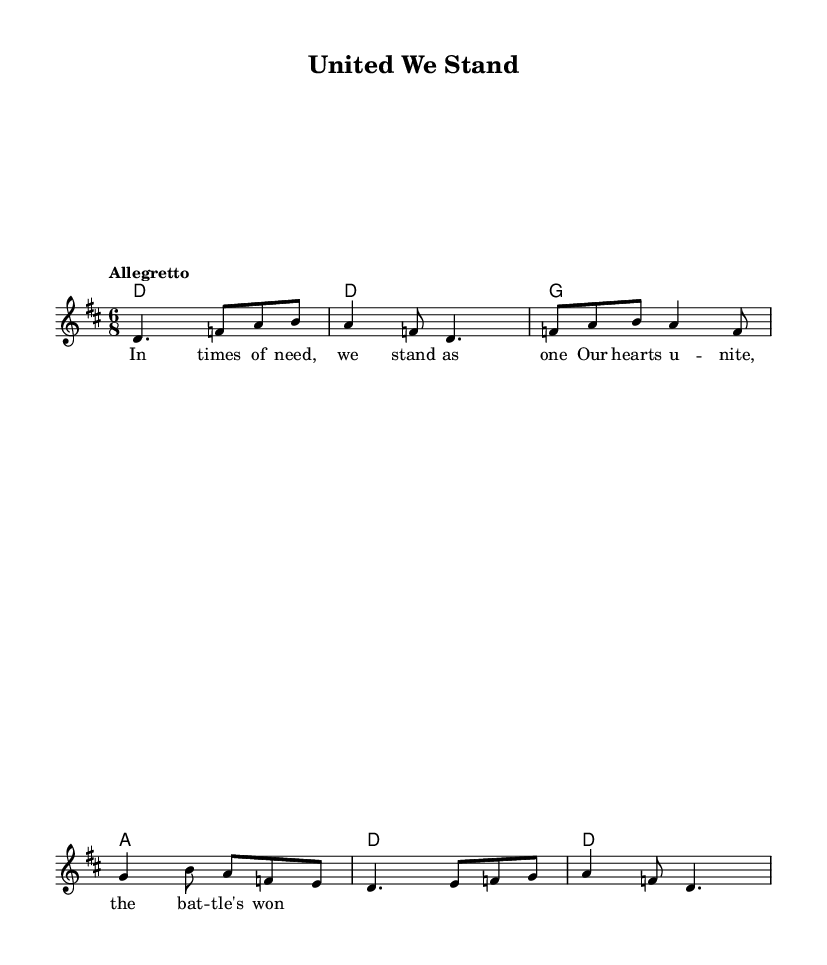What is the key signature of this music? The key signature is indicated by the number of sharps or flats present at the beginning of the staff. In this case, there are two sharps (F# and C#) which indicates that the piece is in D major.
Answer: D major What is the time signature of this music? The time signature is found in the top left corner of the sheet music, shown as two numbers stacked. Here, it is 6 over 8, indicating six beats per measure with an eighth note receiving one beat.
Answer: 6/8 What does the tempo marking indicate? The tempo marking usually indicates how fast the music should be played. In this sheet music, it is marked as "Allegretto," which suggests a moderately fast pace.
Answer: Allegretto How many measures are there in the melody? By counting the groups of notes before each vertical line (bar line), we can determine how many measures are present. There are a total of six groups of notes, which indicates six measures.
Answer: 6 What style of music does this piece represent? The piece is titled "United We Stand" and incorporates elements typical of folk music, such as a narrative feel and community themes. Additionally, the 6/8 time signature is commonly found in Irish folk tunes.
Answer: Folk What is the primary theme conveyed in the lyrics? The lyrics express unity and communal strength during difficult times, which is a common theme in folk music. The specific lyrics mention standing together and winning battles, emphasizing support and solidarity.
Answer: Community support 